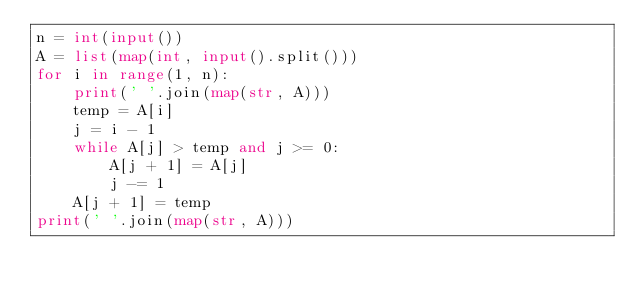<code> <loc_0><loc_0><loc_500><loc_500><_Python_>n = int(input())
A = list(map(int, input().split()))
for i in range(1, n):
    print(' '.join(map(str, A)))
    temp = A[i]
    j = i - 1
    while A[j] > temp and j >= 0:
        A[j + 1] = A[j]
        j -= 1
    A[j + 1] = temp
print(' '.join(map(str, A)))
</code> 